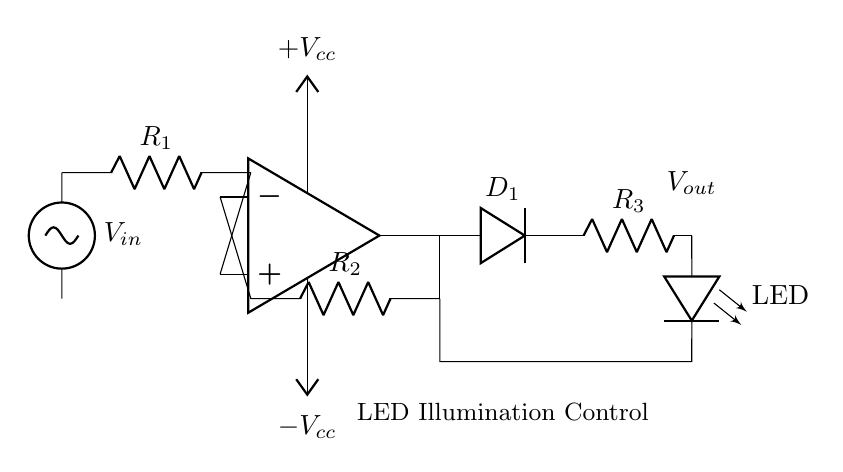What is the function of the op-amp in this circuit? The op-amp serves as a voltage amplifier, providing the necessary gain to control the LED's brightness by amplifying the input voltage signal.
Answer: Voltage amplifier What is the role of the diode labeled D1? The diode D1 allows current to flow in only one direction, ensuring that the output voltage does not drop below zero, thus creating a precision rectifier effect.
Answer: Precision rectifier What are the resistances labeled R1, R2, and R3? R1 and R2 are feedback and input resistors that determine the gain of the op-amp, while R3 serves as a current limiting resistor for the LED.
Answer: R1, R2: feedback/input resistors; R3: LED current limiting What would happen if R3 is removed from the circuit? Removing R3 would likely result in excessive current flowing through the LED, potentially damaging it due to lack of current limiting.
Answer: Damage to LED What is the output voltage Vout relative to Vin in this circuit? The output voltage Vout is a rectified version of the input voltage Vin, primarily controlled by the op-amp and diode configuration, allowing for a proportional LED intensity according to Vin.
Answer: Rectified Vin What is the purpose of the labeled LED in the circuit? The LED is the output component that illuminates at a brightness proportionate to the input voltage, controlled by the precision rectifier circuit.
Answer: Illumination control 